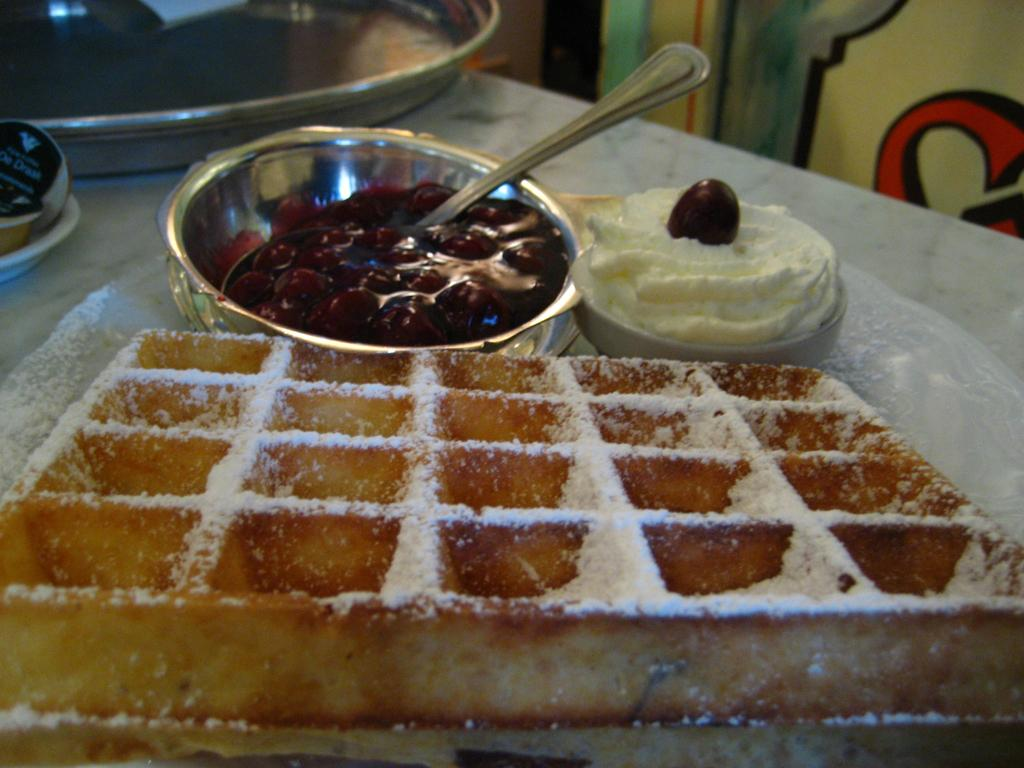What type of objects can be seen in the image? There are food items, bowls, a spoon, and a plate in the image. Can you describe the food items in the image? Unfortunately, the specific food items are not mentioned in the provided facts. What utensil is present in the image? There is a spoon in the image. What type of dishware is present in the image? There is a plate in the image. Are there any other objects in the image besides the food items, bowls, spoon, and plate? Yes, there are some unspecified objects in the image. What type of thread is being used to sew the son's shirt in the image? There is no mention of a son, shirt, or thread in the provided facts, so this question cannot be answered based on the information given. 